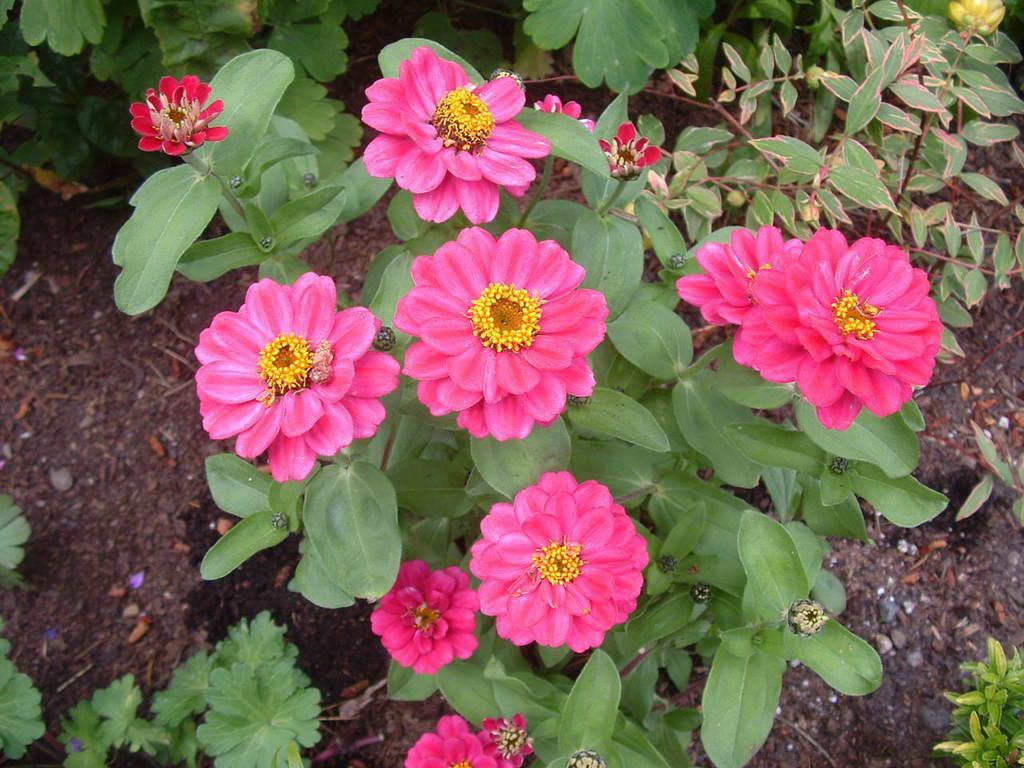Describe this image in one or two sentences. The picture consists of plants and flowers. In the background there is soil. 